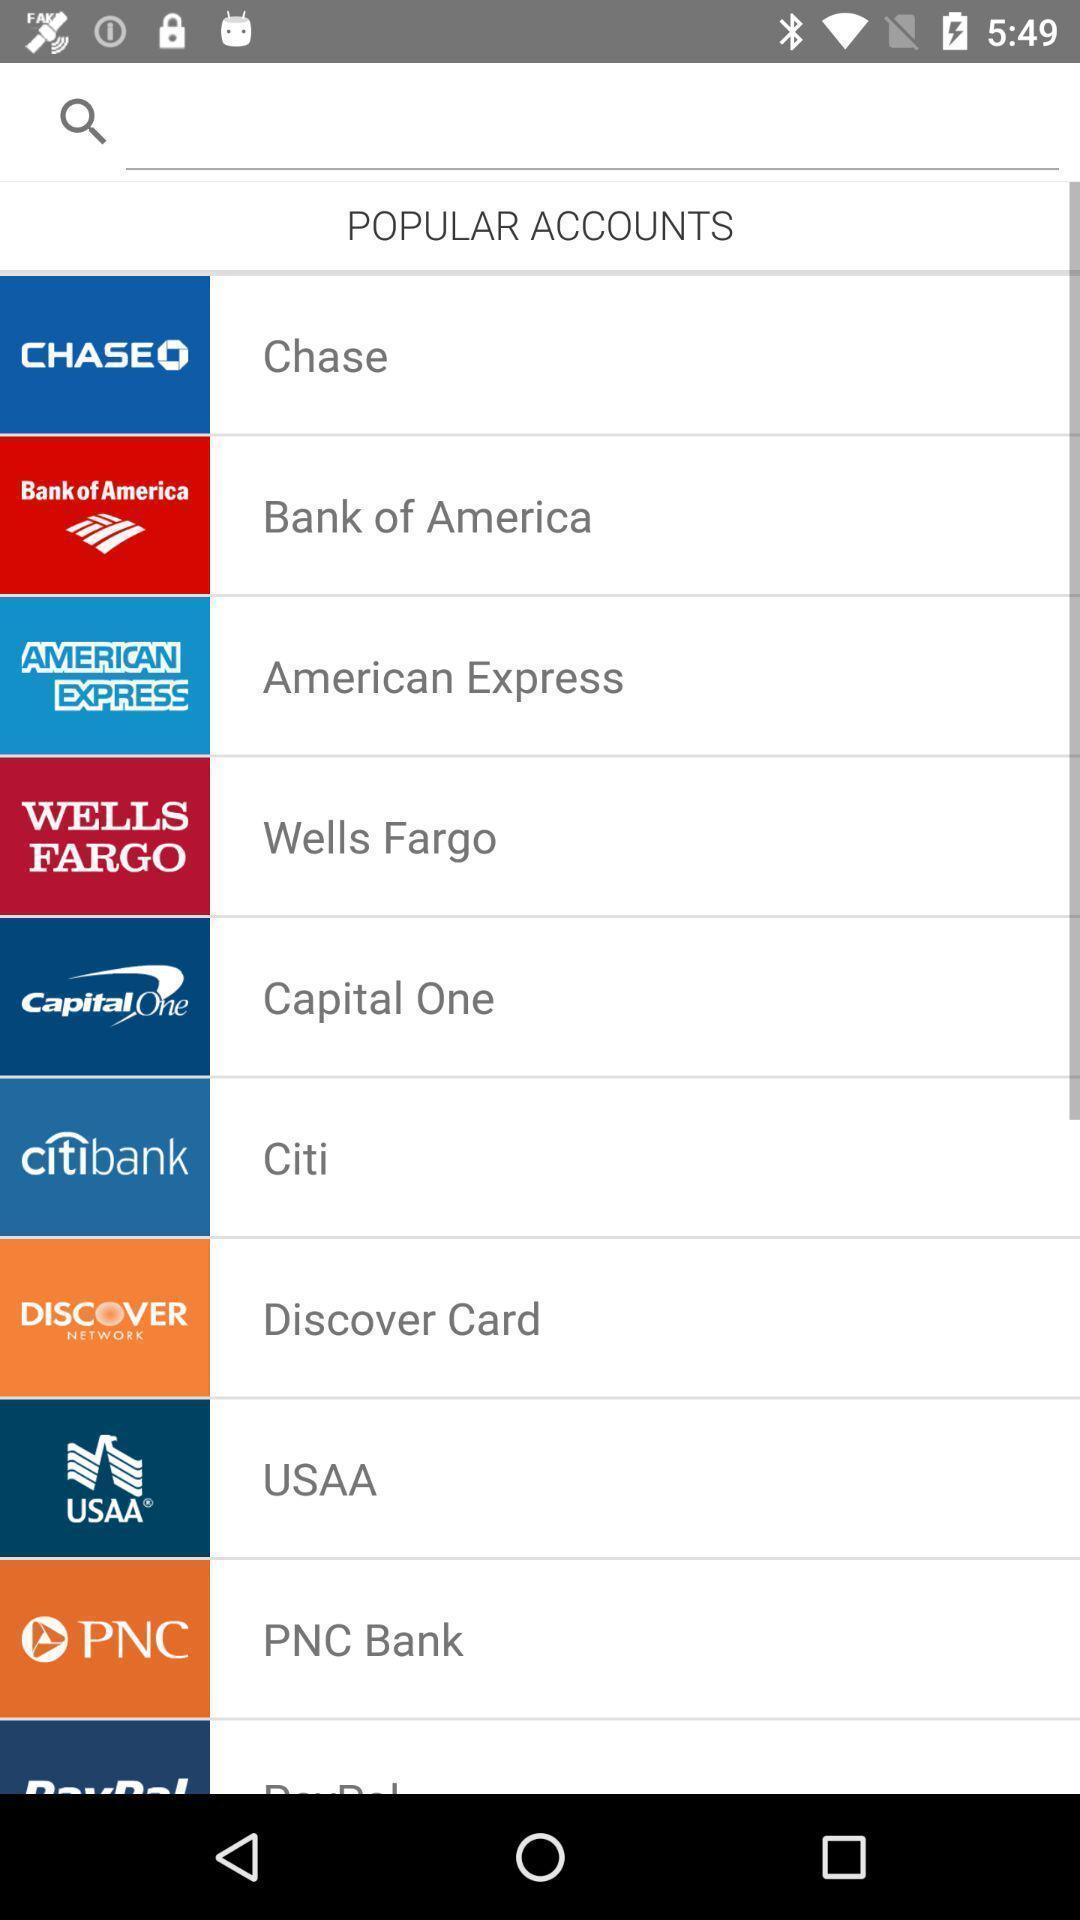Describe this image in words. Page showing list of popular accounts on an app. 